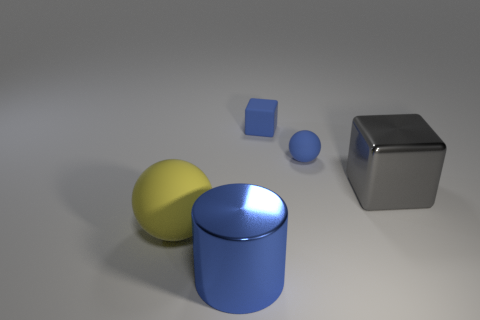Add 4 small matte blocks. How many objects exist? 9 Subtract all yellow balls. How many balls are left? 1 Subtract 1 cylinders. How many cylinders are left? 0 Subtract all cylinders. How many objects are left? 4 Add 4 large blocks. How many large blocks are left? 5 Add 3 big gray shiny things. How many big gray shiny things exist? 4 Subtract 0 cyan cubes. How many objects are left? 5 Subtract all red balls. Subtract all red blocks. How many balls are left? 2 Subtract all green cylinders. How many brown blocks are left? 0 Subtract all yellow objects. Subtract all small cyan metallic objects. How many objects are left? 4 